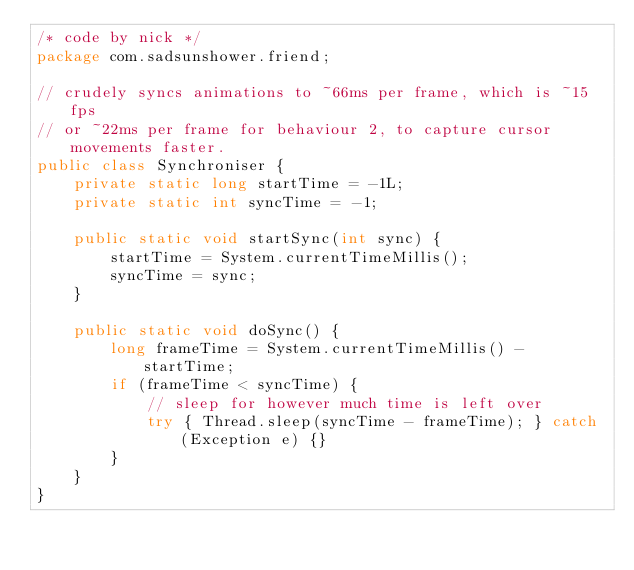<code> <loc_0><loc_0><loc_500><loc_500><_Java_>/* code by nick */
package com.sadsunshower.friend;

// crudely syncs animations to ~66ms per frame, which is ~15fps
// or ~22ms per frame for behaviour 2, to capture cursor movements faster.
public class Synchroniser {
    private static long startTime = -1L;
    private static int syncTime = -1;
    
    public static void startSync(int sync) {
        startTime = System.currentTimeMillis();
        syncTime = sync;
    }
    
    public static void doSync() {
        long frameTime = System.currentTimeMillis() - startTime;
        if (frameTime < syncTime) {
            // sleep for however much time is left over
            try { Thread.sleep(syncTime - frameTime); } catch (Exception e) {}
        }
    }
}
</code> 